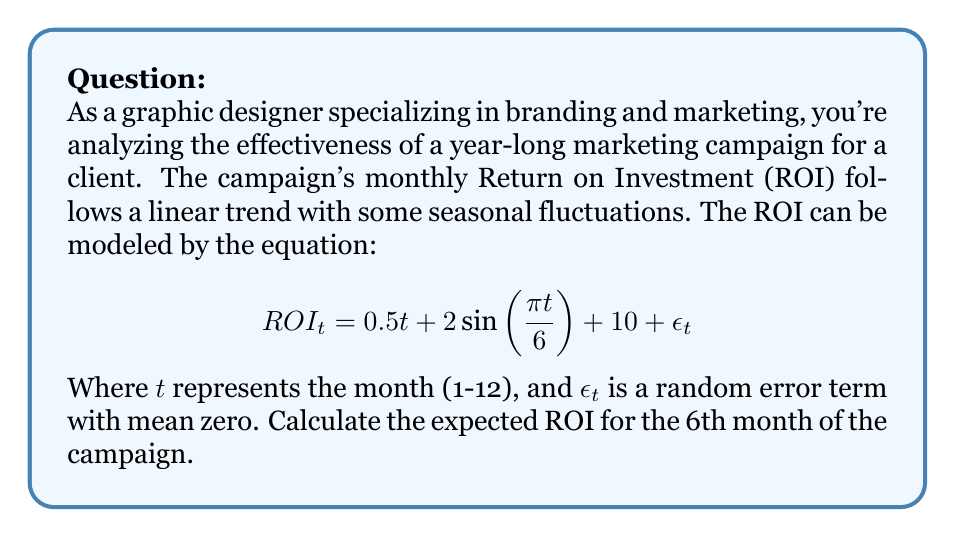Solve this math problem. To solve this problem, we need to use the given time series model and plug in the appropriate value for $t$. Let's break it down step-by-step:

1. We're given the equation:
   $$ROI_t = 0.5t + 2\sin(\frac{\pi t}{6}) + 10 + \epsilon_t$$

2. We need to find the expected ROI for the 6th month, so $t = 6$.

3. Let's substitute $t = 6$ into the equation:
   $$ROI_6 = 0.5(6) + 2\sin(\frac{\pi (6)}{6}) + 10 + \epsilon_6$$

4. Simplify the linear term:
   $$ROI_6 = 3 + 2\sin(\pi) + 10 + \epsilon_6$$

5. Simplify the sine term (remember that $\sin(\pi) = 0$):
   $$ROI_6 = 3 + 2(0) + 10 + \epsilon_6$$

6. Simplify further:
   $$ROI_6 = 13 + \epsilon_6$$

7. To find the expected ROI, we take the expectation of both sides:
   $$E[ROI_6] = E[13 + \epsilon_6]$$

8. The expectation of a constant is the constant itself, and the expectation of $\epsilon_6$ is zero (given in the problem statement):
   $$E[ROI_6] = 13 + E[\epsilon_6] = 13 + 0 = 13$$

Therefore, the expected ROI for the 6th month of the campaign is 13.
Answer: 13 